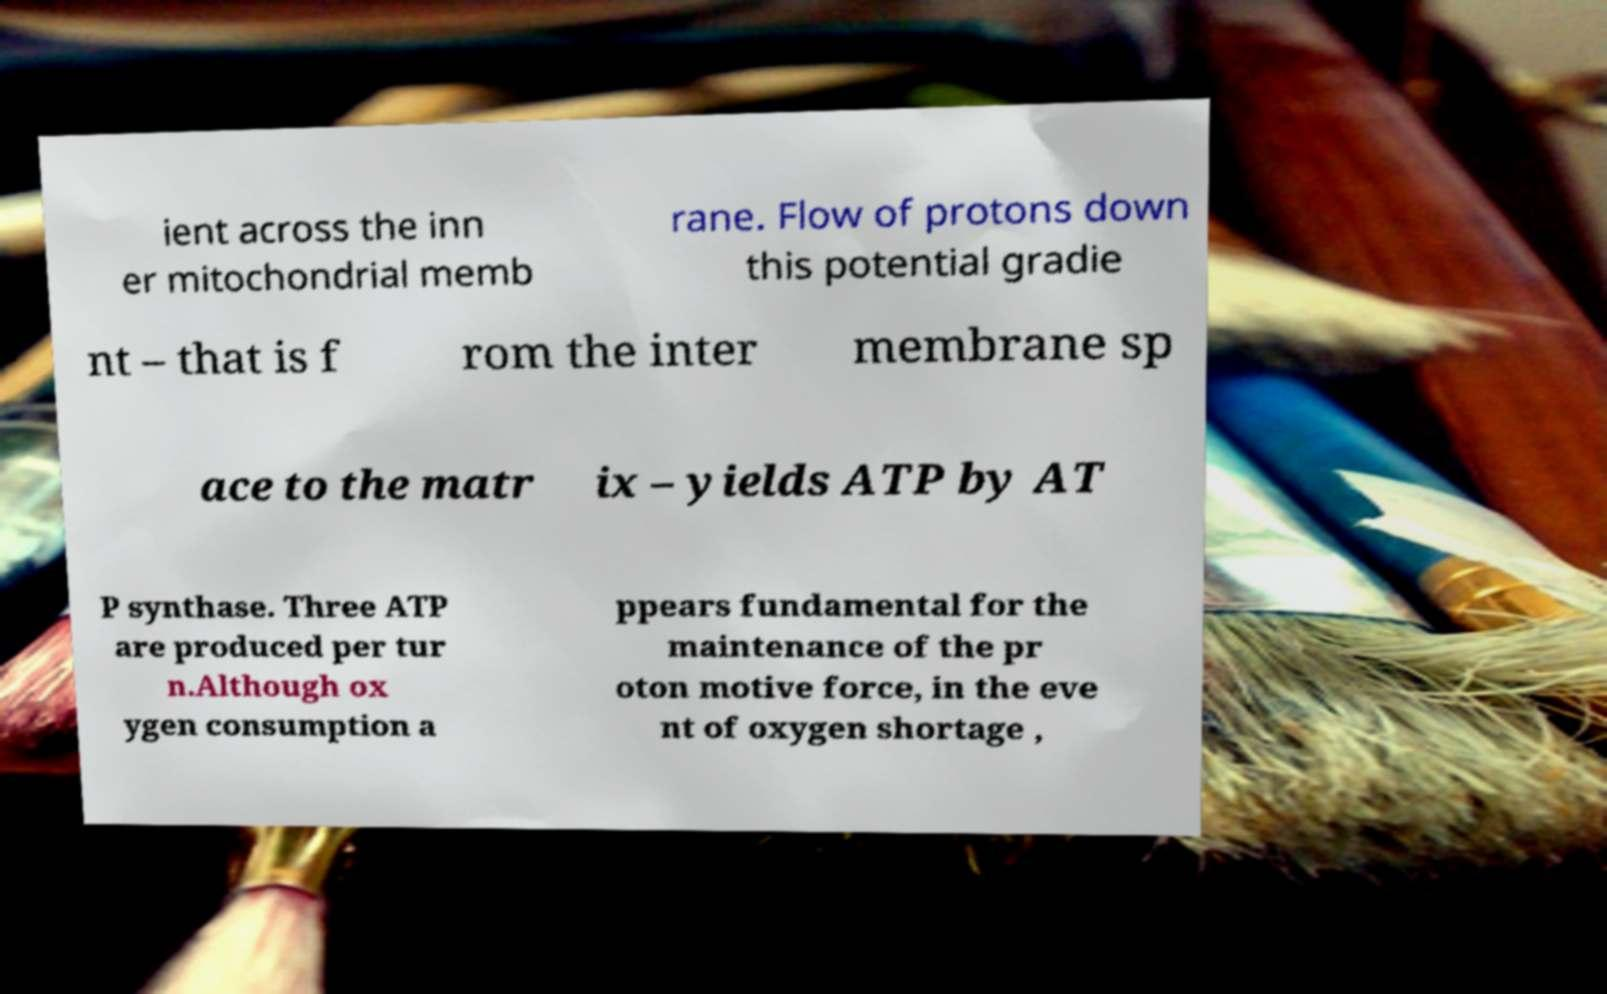I need the written content from this picture converted into text. Can you do that? ient across the inn er mitochondrial memb rane. Flow of protons down this potential gradie nt – that is f rom the inter membrane sp ace to the matr ix – yields ATP by AT P synthase. Three ATP are produced per tur n.Although ox ygen consumption a ppears fundamental for the maintenance of the pr oton motive force, in the eve nt of oxygen shortage , 